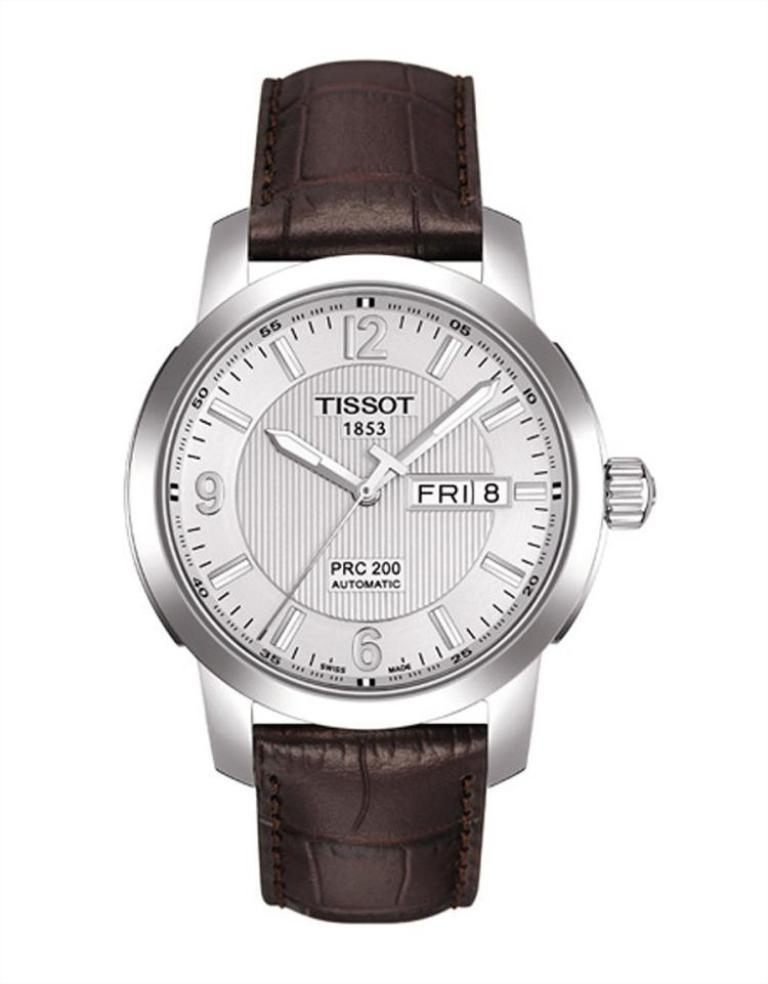Provide a one-sentence caption for the provided image. A Tissot 1853 watch that is all silver and a black band. 